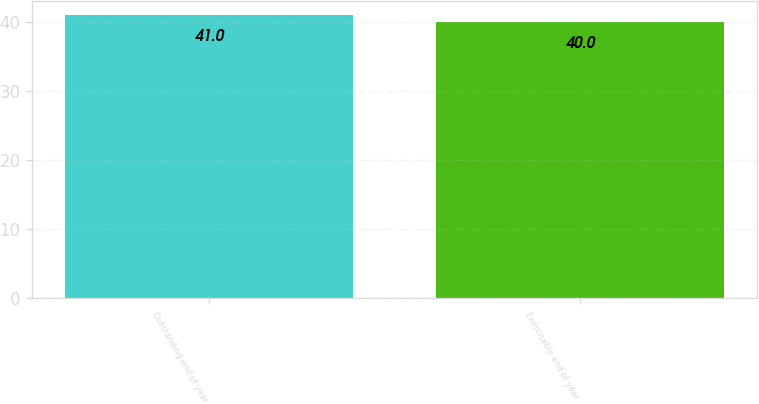Convert chart. <chart><loc_0><loc_0><loc_500><loc_500><bar_chart><fcel>Outstanding end of year<fcel>Exercisable end of year<nl><fcel>41<fcel>40<nl></chart> 